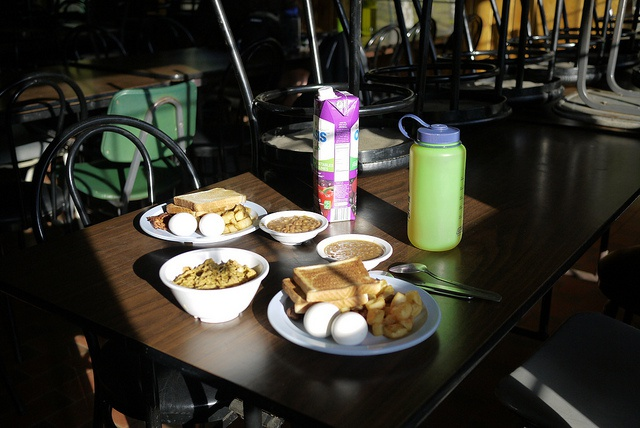Describe the objects in this image and their specific colors. I can see dining table in black, white, olive, and gray tones, chair in black, gray, darkgreen, and darkgray tones, chair in black, gray, green, and darkgreen tones, chair in black and gray tones, and chair in black, gray, and olive tones in this image. 